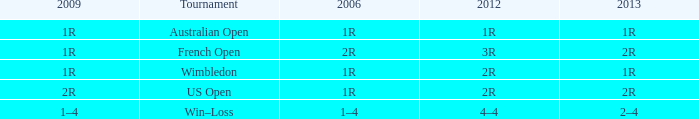What shows for 2006, when 2013 is 2–4? 1–4. 